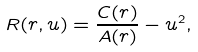Convert formula to latex. <formula><loc_0><loc_0><loc_500><loc_500>R ( r , u ) = \frac { C ( r ) } { A ( r ) } - u ^ { 2 } ,</formula> 